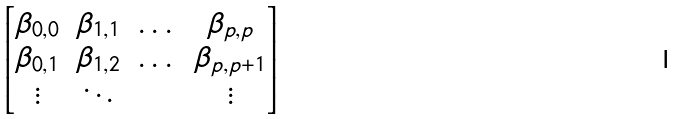<formula> <loc_0><loc_0><loc_500><loc_500>\begin{bmatrix} \beta _ { 0 , 0 } & \beta _ { 1 , 1 } & \dots & \beta _ { p , p } \\ \beta _ { 0 , 1 } & \beta _ { 1 , 2 } & \dots & \beta _ { p , p + 1 } \\ \vdots & \ddots & & \vdots \end{bmatrix}</formula> 